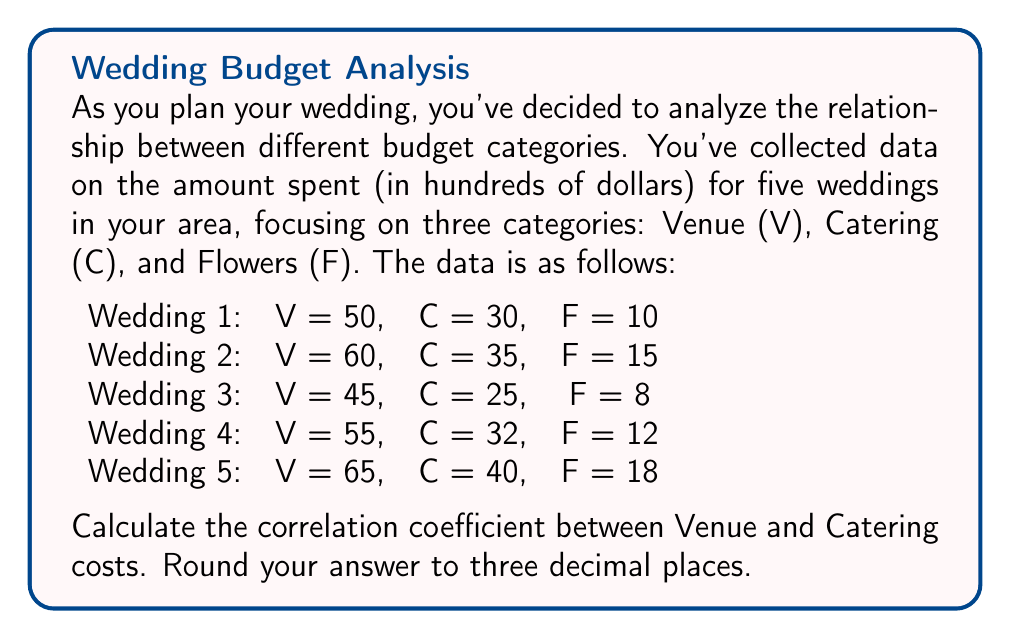Show me your answer to this math problem. To calculate the correlation coefficient between Venue (V) and Catering (C) costs, we'll use the Pearson correlation coefficient formula:

$$r_{VC} = \frac{\sum_{i=1}^n (V_i - \bar{V})(C_i - \bar{C})}{\sqrt{\sum_{i=1}^n (V_i - \bar{V})^2 \sum_{i=1}^n (C_i - \bar{C})^2}}$$

Where $\bar{V}$ and $\bar{C}$ are the means of V and C respectively.

Step 1: Calculate the means
$\bar{V} = \frac{50 + 60 + 45 + 55 + 65}{5} = 55$
$\bar{C} = \frac{30 + 35 + 25 + 32 + 40}{5} = 32.4$

Step 2: Calculate $(V_i - \bar{V})$ and $(C_i - \bar{C})$ for each wedding
Wedding 1: $V_1 - \bar{V} = 50 - 55 = -5$, $C_1 - \bar{C} = 30 - 32.4 = -2.4$
Wedding 2: $V_2 - \bar{V} = 60 - 55 = 5$, $C_2 - \bar{C} = 35 - 32.4 = 2.6$
Wedding 3: $V_3 - \bar{V} = 45 - 55 = -10$, $C_3 - \bar{C} = 25 - 32.4 = -7.4$
Wedding 4: $V_4 - \bar{V} = 55 - 55 = 0$, $C_4 - \bar{C} = 32 - 32.4 = -0.4$
Wedding 5: $V_5 - \bar{V} = 65 - 55 = 10$, $C_5 - \bar{C} = 40 - 32.4 = 7.6$

Step 3: Calculate the numerator $\sum_{i=1}^n (V_i - \bar{V})(C_i - \bar{C})$
$(-5)(-2.4) + (5)(2.6) + (-10)(-7.4) + (0)(-0.4) + (10)(7.6) = 12 + 13 + 74 + 0 + 76 = 175$

Step 4: Calculate $\sum_{i=1}^n (V_i - \bar{V})^2$ and $\sum_{i=1}^n (C_i - \bar{C})^2$
$\sum_{i=1}^n (V_i - \bar{V})^2 = (-5)^2 + (5)^2 + (-10)^2 + (0)^2 + (10)^2 = 25 + 25 + 100 + 0 + 100 = 250$
$\sum_{i=1}^n (C_i - \bar{C})^2 = (-2.4)^2 + (2.6)^2 + (-7.4)^2 + (-0.4)^2 + (7.6)^2 = 5.76 + 6.76 + 54.76 + 0.16 + 57.76 = 125.2$

Step 5: Calculate the correlation coefficient
$$r_{VC} = \frac{175}{\sqrt{250 \times 125.2}} = \frac{175}{\sqrt{31300}} = \frac{175}{176.918} = 0.989$$

Rounding to three decimal places: 0.989
Answer: 0.989 